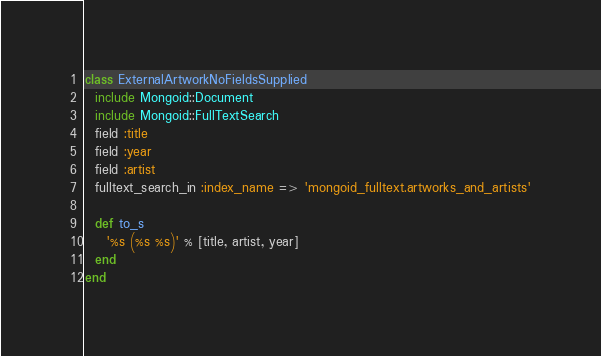Convert code to text. <code><loc_0><loc_0><loc_500><loc_500><_Ruby_>class ExternalArtworkNoFieldsSupplied
  include Mongoid::Document
  include Mongoid::FullTextSearch
  field :title
  field :year
  field :artist
  fulltext_search_in :index_name => 'mongoid_fulltext.artworks_and_artists'

  def to_s
    '%s (%s %s)' % [title, artist, year] 
  end
end
</code> 